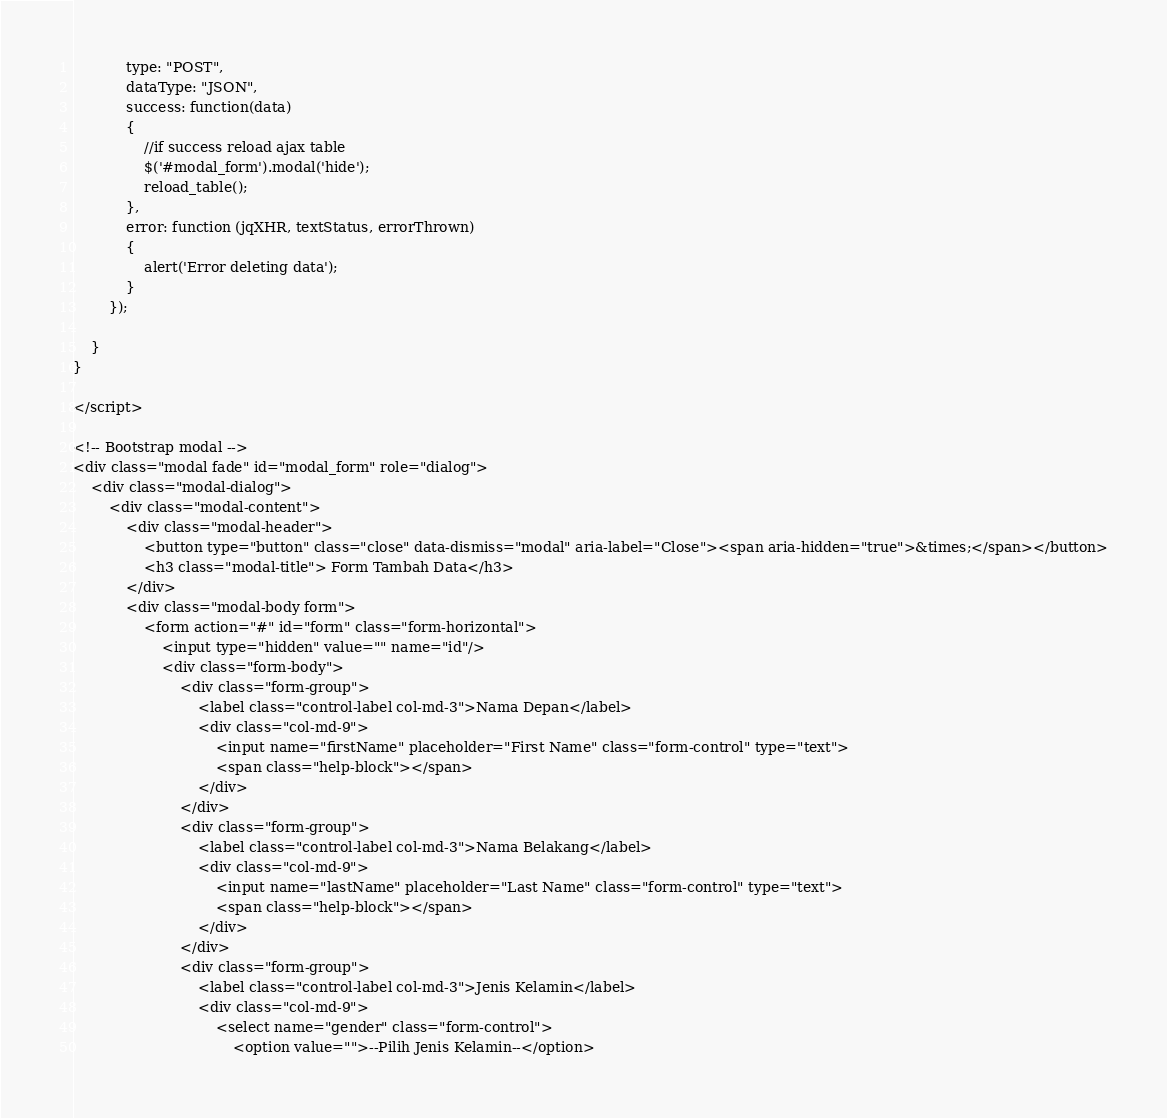Convert code to text. <code><loc_0><loc_0><loc_500><loc_500><_PHP_>            type: "POST",
            dataType: "JSON",
            success: function(data)
            {
                //if success reload ajax table
                $('#modal_form').modal('hide');
                reload_table();
            },
            error: function (jqXHR, textStatus, errorThrown)
            {
                alert('Error deleting data');
            }
        });

    }
}

</script>

<!-- Bootstrap modal -->
<div class="modal fade" id="modal_form" role="dialog">
    <div class="modal-dialog">
        <div class="modal-content">
            <div class="modal-header">
                <button type="button" class="close" data-dismiss="modal" aria-label="Close"><span aria-hidden="true">&times;</span></button>
                <h3 class="modal-title"> Form Tambah Data</h3>
            </div>
            <div class="modal-body form">
                <form action="#" id="form" class="form-horizontal">
                    <input type="hidden" value="" name="id"/> 
                    <div class="form-body">
                        <div class="form-group">
                            <label class="control-label col-md-3">Nama Depan</label>
                            <div class="col-md-9">
                                <input name="firstName" placeholder="First Name" class="form-control" type="text">
                                <span class="help-block"></span>
                            </div>
                        </div>
                        <div class="form-group">
                            <label class="control-label col-md-3">Nama Belakang</label>
                            <div class="col-md-9">
                                <input name="lastName" placeholder="Last Name" class="form-control" type="text">
                                <span class="help-block"></span>
                            </div>
                        </div>
                        <div class="form-group">
                            <label class="control-label col-md-3">Jenis Kelamin</label>
                            <div class="col-md-9">
                                <select name="gender" class="form-control">
                                    <option value="">--Pilih Jenis Kelamin--</option></code> 